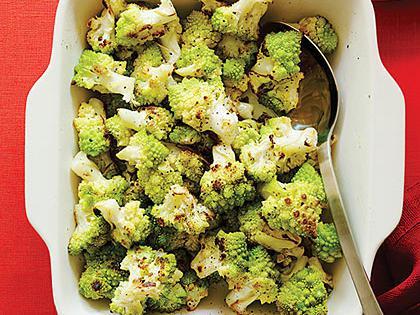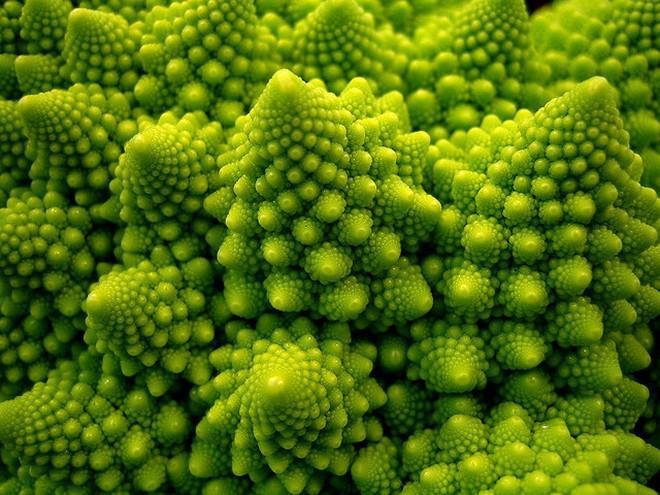The first image is the image on the left, the second image is the image on the right. Assess this claim about the two images: "The image on the left contains cooked food.". Correct or not? Answer yes or no. Yes. 